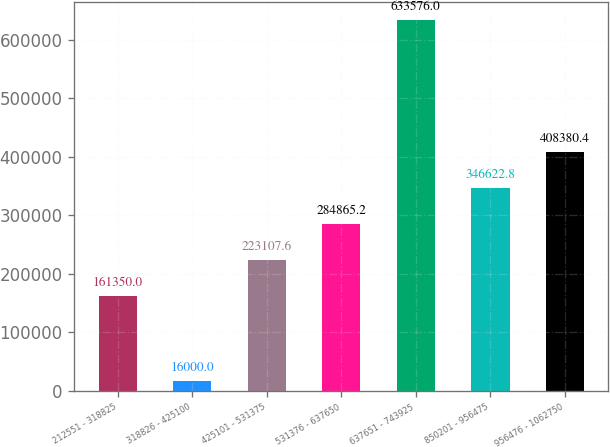<chart> <loc_0><loc_0><loc_500><loc_500><bar_chart><fcel>212551 - 318825<fcel>318826 - 425100<fcel>425101 - 531375<fcel>531376 - 637650<fcel>637651 - 743925<fcel>850201 - 956475<fcel>956476 - 1062750<nl><fcel>161350<fcel>16000<fcel>223108<fcel>284865<fcel>633576<fcel>346623<fcel>408380<nl></chart> 